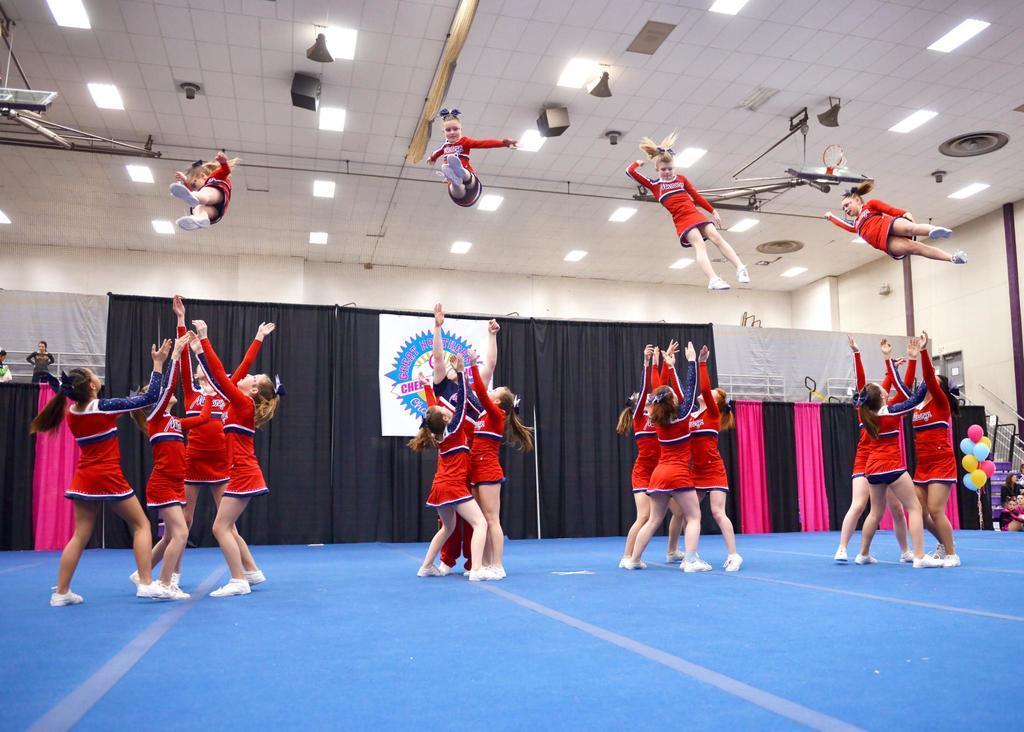In one or two sentences, can you explain what this image depicts? In this picture we can see there are groups of people. Behind the people, there are curtains and a banner. On the right side of the image, there are balloons and railing. At the top of the image, there are ceiling lights and some objects. 